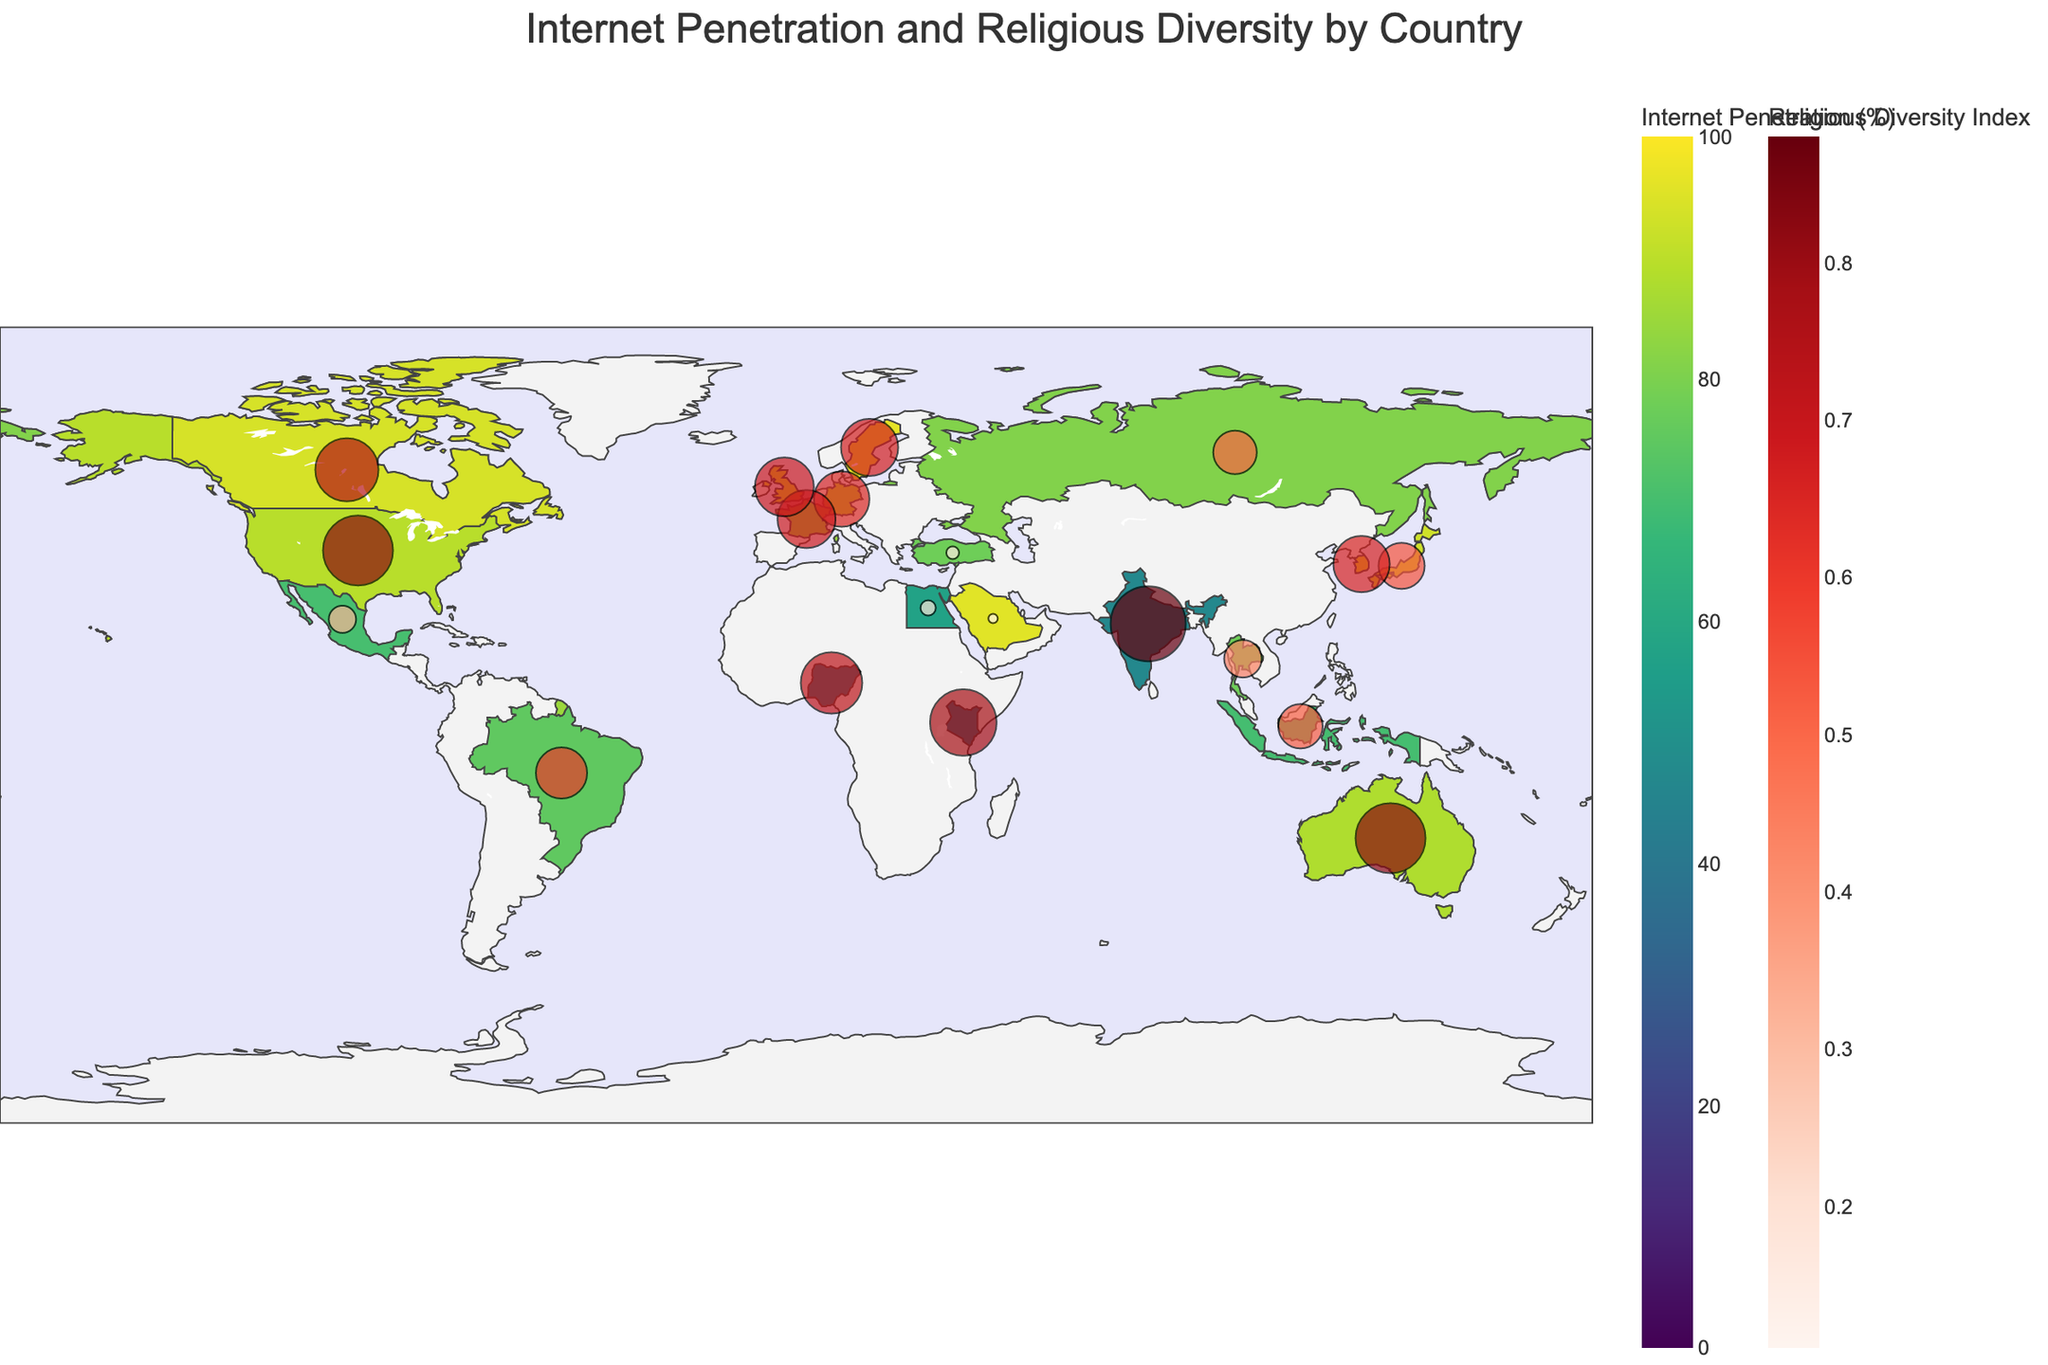What is the title of the figure? The title is typically displayed at the top of the figure. In this case, it is "Internet Penetration and Religious Diversity by Country".
Answer: Internet Penetration and Religious Diversity by Country Which country has the highest internet penetration rate? By examining the color intensity on the choropleth map, the country with the highest internet penetration rate can be identified. From the provided data, it's Sweden with an internet penetration rate of 96.5%.
Answer: Sweden What is the religious diversity index for Canada? The religious diversity index is indicated by the size and color of the markers on the map. By locating Canada and referring to the hover information, we can identify that Canada has a religious diversity index of 0.74.
Answer: 0.74 Which region shows a combination of high internet penetration and high religious diversity? Countries with both high internet penetration rates (darker shades of green) and larger red markers indicate high religious diversity. From the data provided, Australia fits this description with an internet penetration of 88.0% and a religious diversity index of 0.82.
Answer: Australia Compare the internet penetration rates of India and Nigeria. Which country has a lower rate? By identifying the locations of India and Nigeria on the map and comparing their shades of green, it can be noted that Nigeria has a darker shade indicating a lower internet penetration rate. Specifically, Nigeria has 42.0% and India has 47.0%.
Answer: Nigeria What is the relationship between internet penetration and religious diversity for Saudi Arabia? Locate Saudi Arabia on the map and examine both the color and the marker size. Saudi Arabia has a high internet penetration rate of 95.7% but a very low religious diversity index of 0.11, indicating that internet penetration does not necessarily correlate with higher religious diversity.
Answer: High internet penetration, low religious diversity What does the color scale on the map represent? The color scale ranging from lighter to darker green represents the internet penetration rates from low to high across different countries.
Answer: Internet penetration rates Which country in the provided data has the greatest disparity between high internet penetration and low religious diversity? By comparing the provided data for internet penetration and religious diversity index, Saudi Arabia has a high internet penetration rate of 95.7% but a low religious diversity index of 0.11.
Answer: Saudi Arabia Identify a country with moderate internet penetration and high religious diversity. Look for countries with internet penetration in a medium shade of green combined with larger marker sizes. From the provided data, Brazil with 75.0% internet penetration and a 0.60 religious diversity index matches this description.
Answer: Brazil How does the religious diversity index for Egypt compare to that of the United Kingdom? Locate Egypt and the United Kingdom on the map. Egypt's marker is smaller and less intense, indicating a lower religious diversity index (0.18) compared to the United Kingdom's larger, more intense marker (0.69).
Answer: Lower 